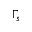Convert formula to latex. <formula><loc_0><loc_0><loc_500><loc_500>\Gamma _ { s }</formula> 